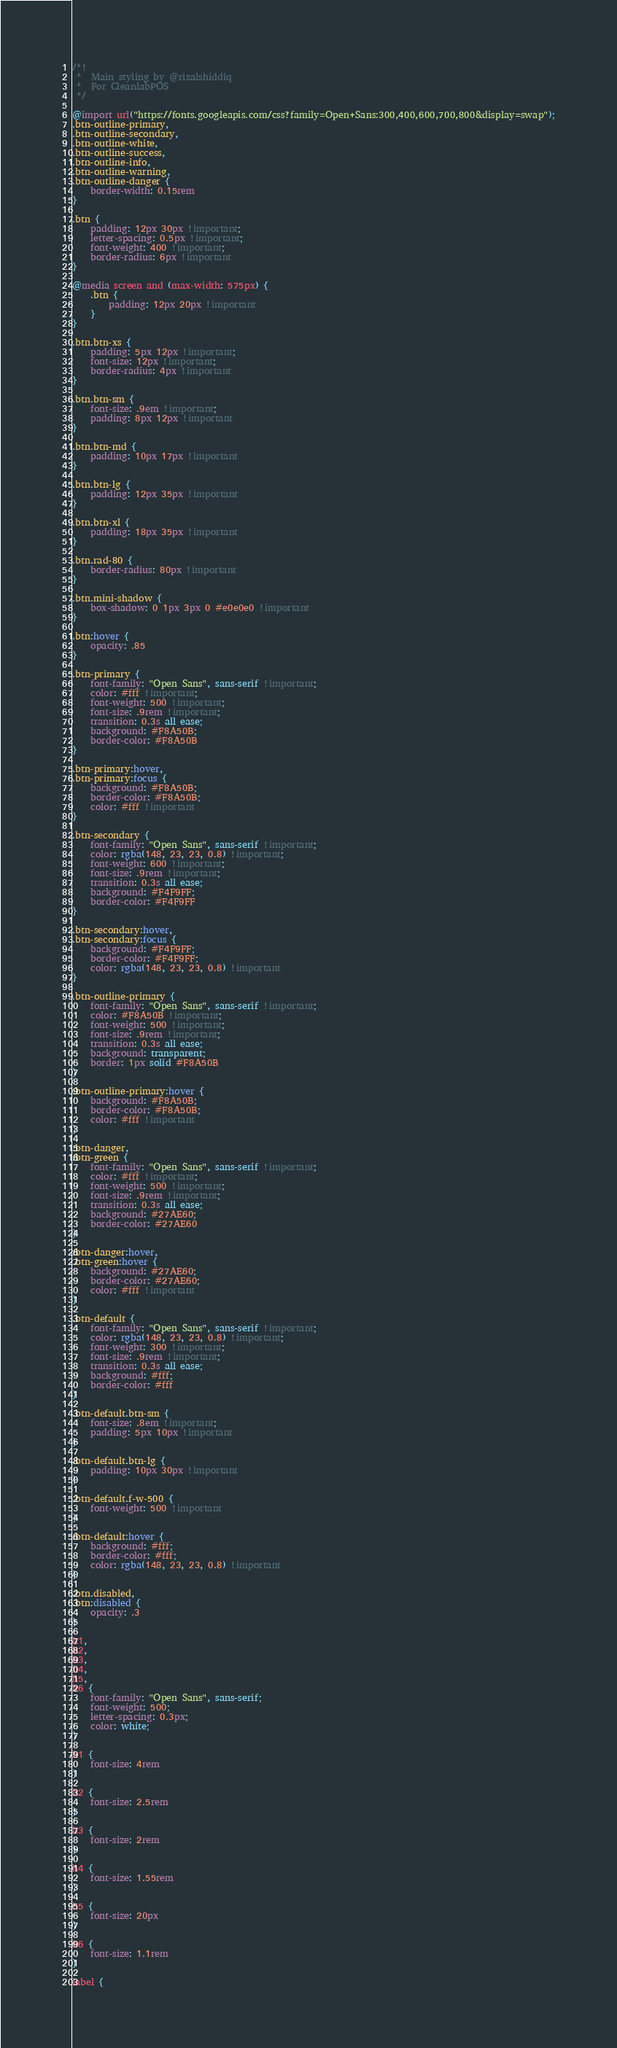Convert code to text. <code><loc_0><loc_0><loc_500><loc_500><_CSS_>/*!
 *  Main styling by @rizalshiddiq
 * 	For CleanlabPOS
 */

@import url("https://fonts.googleapis.com/css?family=Open+Sans:300,400,600,700,800&display=swap");
.btn-outline-primary,
.btn-outline-secondary,
.btn-outline-white,
.btn-outline-success,
.btn-outline-info,
.btn-outline-warning,
.btn-outline-danger {
    border-width: 0.15rem
}

.btn {
    padding: 12px 30px !important;
    letter-spacing: 0.5px !important;
    font-weight: 400 !important;
    border-radius: 6px !important
}

@media screen and (max-width: 575px) {
    .btn {
        padding: 12px 20px !important
    }
}

.btn.btn-xs {
    padding: 5px 12px !important;
    font-size: 12px !important;
    border-radius: 4px !important
}

.btn.btn-sm {
    font-size: .9em !important;
    padding: 8px 12px !important
}

.btn.btn-md {
    padding: 10px 17px !important
}

.btn.btn-lg {
    padding: 12px 35px !important
}

.btn.btn-xl {
    padding: 18px 35px !important
}

.btn.rad-80 {
    border-radius: 80px !important
}

.btn.mini-shadow {
    box-shadow: 0 1px 3px 0 #e0e0e0 !important
}

.btn:hover {
    opacity: .85
}

.btn-primary {
    font-family: "Open Sans", sans-serif !important;
    color: #fff !important;
    font-weight: 500 !important;
    font-size: .9rem !important;
    transition: 0.3s all ease;
    background: #F8A50B;
    border-color: #F8A50B
}

.btn-primary:hover,
.btn-primary:focus {
    background: #F8A50B;
    border-color: #F8A50B;
    color: #fff !important
}

.btn-secondary {
    font-family: "Open Sans", sans-serif !important;
    color: rgba(148, 23, 23, 0.8) !important;
    font-weight: 600 !important;
    font-size: .9rem !important;
    transition: 0.3s all ease;
    background: #F4F9FF;
    border-color: #F4F9FF
}

.btn-secondary:hover,
.btn-secondary:focus {
    background: #F4F9FF;
    border-color: #F4F9FF;
    color: rgba(148, 23, 23, 0.8) !important
}

.btn-outline-primary {
    font-family: "Open Sans", sans-serif !important;
    color: #F8A50B !important;
    font-weight: 500 !important;
    font-size: .9rem !important;
    transition: 0.3s all ease;
    background: transparent;
    border: 1px solid #F8A50B
}

.btn-outline-primary:hover {
    background: #F8A50B;
    border-color: #F8A50B;
    color: #fff !important
}

.btn-danger,
.btn-green {
    font-family: "Open Sans", sans-serif !important;
    color: #fff !important;
    font-weight: 500 !important;
    font-size: .9rem !important;
    transition: 0.3s all ease;
    background: #27AE60;
    border-color: #27AE60
}

.btn-danger:hover,
.btn-green:hover {
    background: #27AE60;
    border-color: #27AE60;
    color: #fff !important
}

.btn-default {
    font-family: "Open Sans", sans-serif !important;
    color: rgba(148, 23, 23, 0.8) !important;
    font-weight: 300 !important;
    font-size: .9rem !important;
    transition: 0.3s all ease;
    background: #fff;
    border-color: #fff
}

.btn-default.btn-sm {
    font-size: .8em !important;
    padding: 5px 10px !important
}

.btn-default.btn-lg {
    padding: 10px 30px !important
}

.btn-default.f-w-500 {
    font-weight: 500 !important
}

.btn-default:hover {
    background: #fff;
    border-color: #fff;
    color: rgba(148, 23, 23, 0.8) !important
}

.btn.disabled,
.btn:disabled {
    opacity: .3
}

h1,
h2,
h3,
h4,
h5,
h6 {
    font-family: "Open Sans", sans-serif;
    font-weight: 500;
    letter-spacing: 0.3px;
    color: white;
}

h1 {
    font-size: 4rem
}

h2 {
    font-size: 2.5rem
}

h3 {
    font-size: 2rem
}

h4 {
    font-size: 1.55rem
}

h5 {
    font-size: 20px
}

h6 {
    font-size: 1.1rem
}

label {</code> 